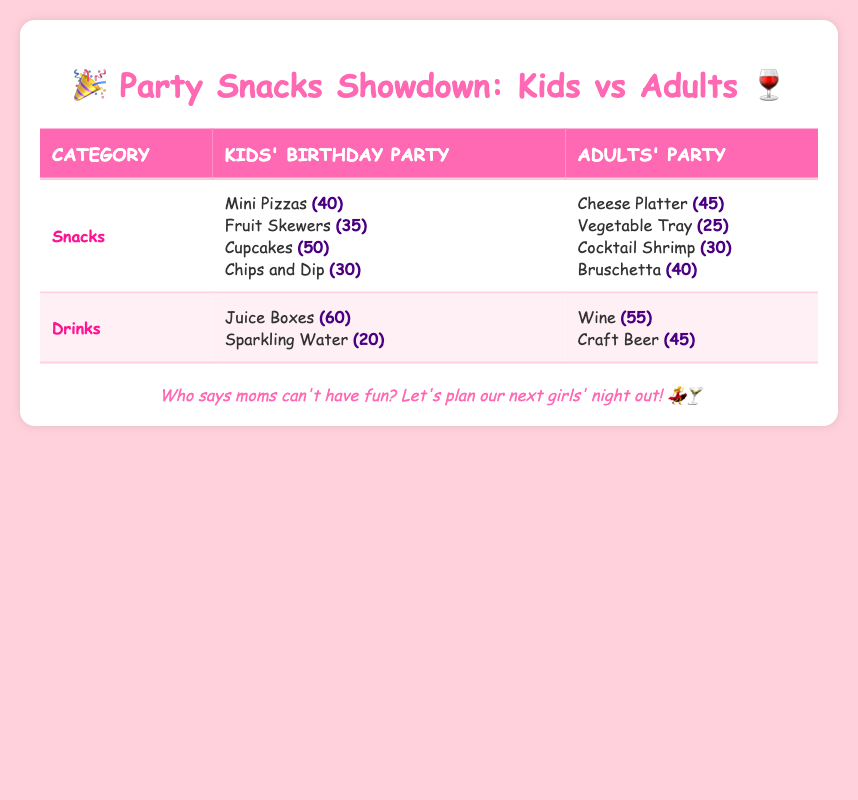What are the total snack counts for the Kids' Birthday Party? To find the total snack counts for the Kids' Birthday Party, we will sum the counts of all snacks listed under that category: 40 (Mini Pizzas) + 35 (Fruit Skewers) + 50 (Cupcakes) + 30 (Chips and Dip) = 155.
Answer: 155 Which snack had the highest count at the Adults' Party? By looking at the snacks listed for the Adults' Party, we see the counts are: 45 (Cheese Platter), 25 (Vegetable Tray), 30 (Cocktail Shrimp), and 40 (Bruschetta). The highest count is 45, corresponding to the Cheese Platter.
Answer: Cheese Platter Is there more juice served at Kids' Birthday Parties than wine at Adults' Parties? The Kids' Birthday Party has 60 Juice Boxes, while the Adults' Party has 55 Wine. Since 60 is greater than 55, the statement is true.
Answer: Yes What is the total count of drinks served at Kids' Birthday Parties? To determine the total drinks for Kids' Birthday Parties, we sum the counts: 60 (Juice Boxes) + 20 (Sparkling Water) = 80.
Answer: 80 How many more snacks are served at Kids' Birthday Parties than at Adults' Parties? First, we find the total number of snacks served at both parties. For Kids' Parties, the total is 155 (from an earlier calculation). For Adults' Parties, the counts are: 45 (Cheese Platter) + 25 (Vegetable Tray) + 30 (Cocktail Shrimp) + 40 (Bruschetta) = 140. The difference is 155 - 140 = 15.
Answer: 15 What is the average count of snacks at Kids' Birthday Parties? To find the average, we first sum the counts: 40 + 35 + 50 + 30 = 155. There are 4 snacks, so the average is 155 / 4 = 38.75.
Answer: 38.75 Are Chips and Dip the second most popular snack at Kids' Birthday Parties? The counts for Kids' snacks rank as follows: Cupcakes (50), Mini Pizzas (40), Chips and Dip (30), and Fruit Skewers (35). Since Chips and Dip is not in the top two, the statement is false.
Answer: No Which drink is less popular at Kids' Birthday Parties, Juice Boxes, or Sparkling Water? Juice Boxes have a count of 60 while Sparkling Water has a count of 20. Since 20 is less than 60, Sparkling Water is the less popular option.
Answer: Sparkling Water How many total food items are served at Adults' Parties? Total food items at Adults' Parties include 4 snacks. Therefore the total count is 4.
Answer: 4 